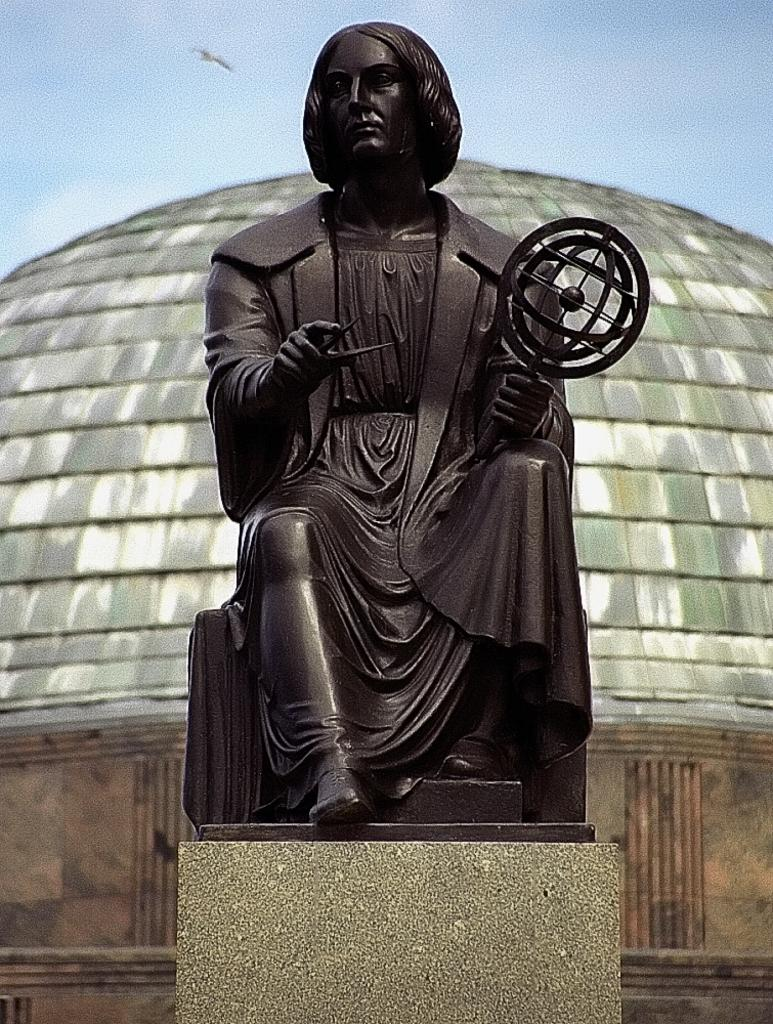What is the main subject in the center of the image? There is a statue in the center of the image. What can be seen in the background of the image? There is a building in the background of the image. What is visible at the top of the image? The sky is visible at the top of the image. What type of hair can be seen on the statue in the image? There is no hair present on the statue in the image. What attraction is nearby the statue in the image? The provided facts do not mention any nearby attractions; only the statue, building, and sky are visible in the image. 